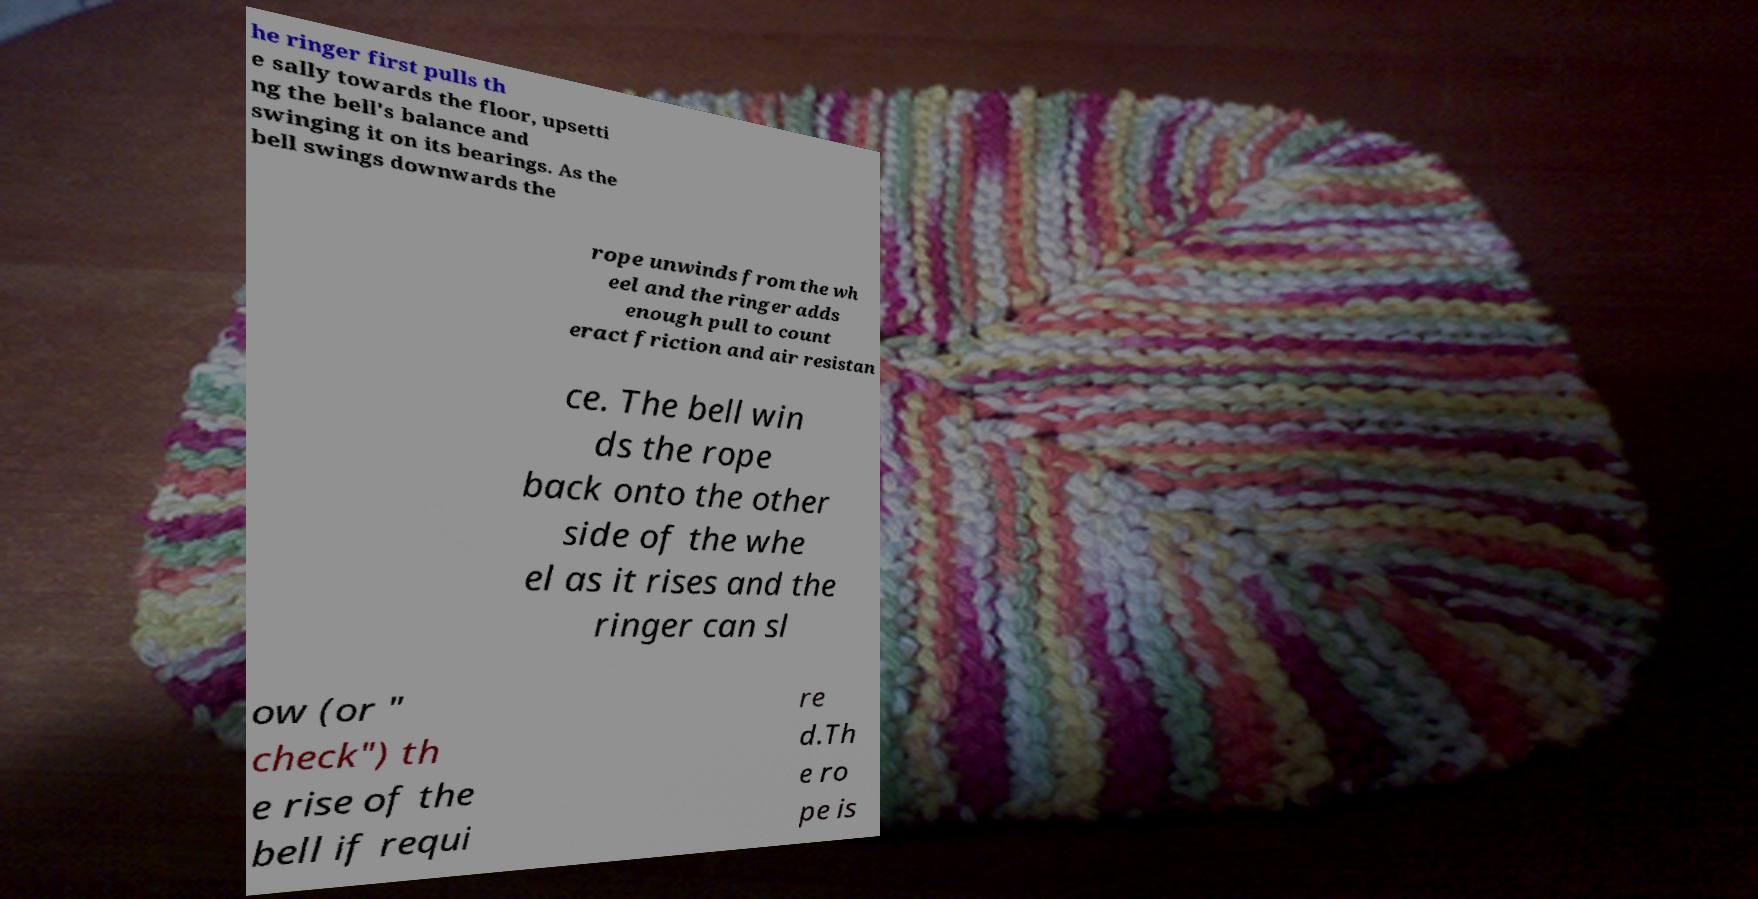Can you accurately transcribe the text from the provided image for me? he ringer first pulls th e sally towards the floor, upsetti ng the bell's balance and swinging it on its bearings. As the bell swings downwards the rope unwinds from the wh eel and the ringer adds enough pull to count eract friction and air resistan ce. The bell win ds the rope back onto the other side of the whe el as it rises and the ringer can sl ow (or " check") th e rise of the bell if requi re d.Th e ro pe is 